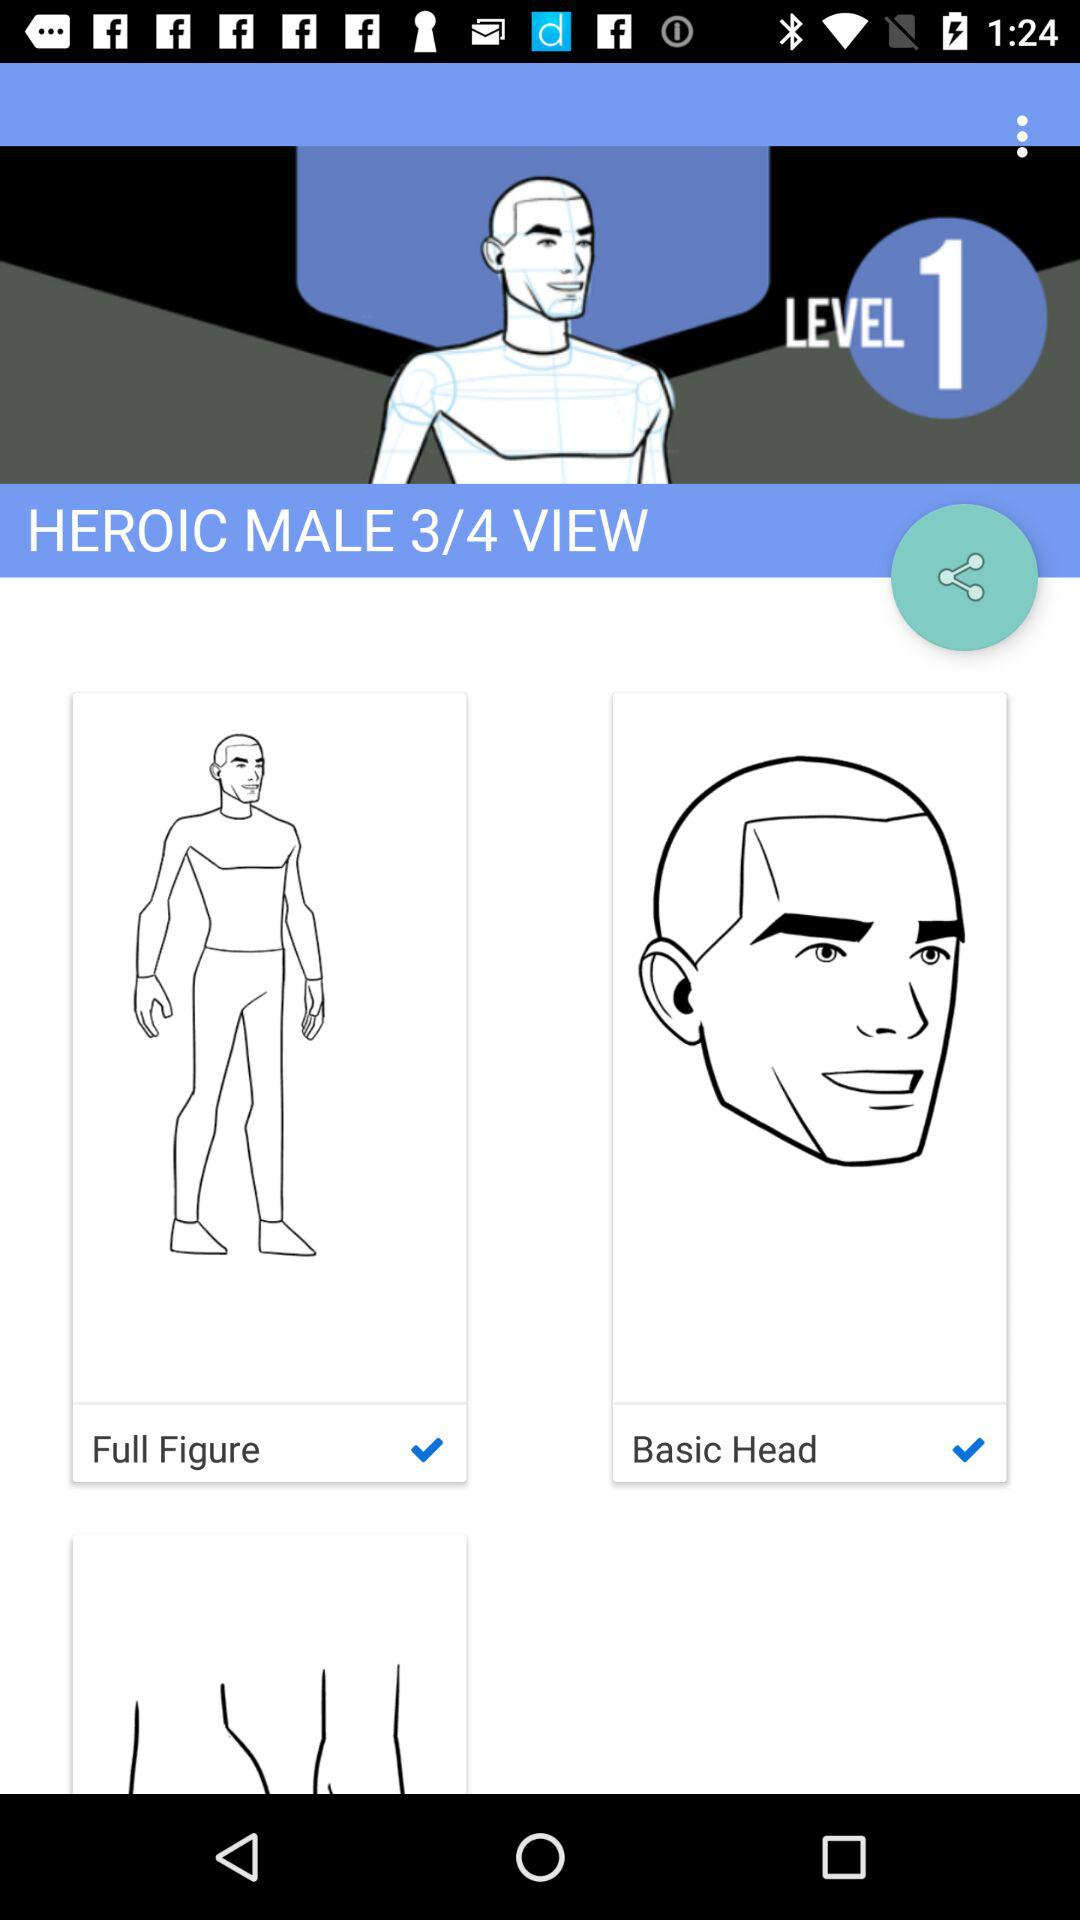How many items have check marks?
Answer the question using a single word or phrase. 2 